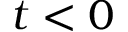Convert formula to latex. <formula><loc_0><loc_0><loc_500><loc_500>t < 0</formula> 